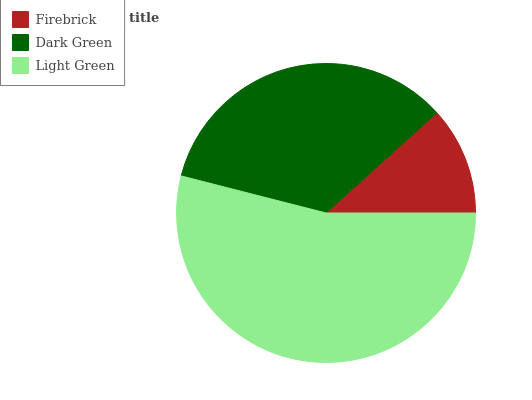Is Firebrick the minimum?
Answer yes or no. Yes. Is Light Green the maximum?
Answer yes or no. Yes. Is Dark Green the minimum?
Answer yes or no. No. Is Dark Green the maximum?
Answer yes or no. No. Is Dark Green greater than Firebrick?
Answer yes or no. Yes. Is Firebrick less than Dark Green?
Answer yes or no. Yes. Is Firebrick greater than Dark Green?
Answer yes or no. No. Is Dark Green less than Firebrick?
Answer yes or no. No. Is Dark Green the high median?
Answer yes or no. Yes. Is Dark Green the low median?
Answer yes or no. Yes. Is Firebrick the high median?
Answer yes or no. No. Is Firebrick the low median?
Answer yes or no. No. 